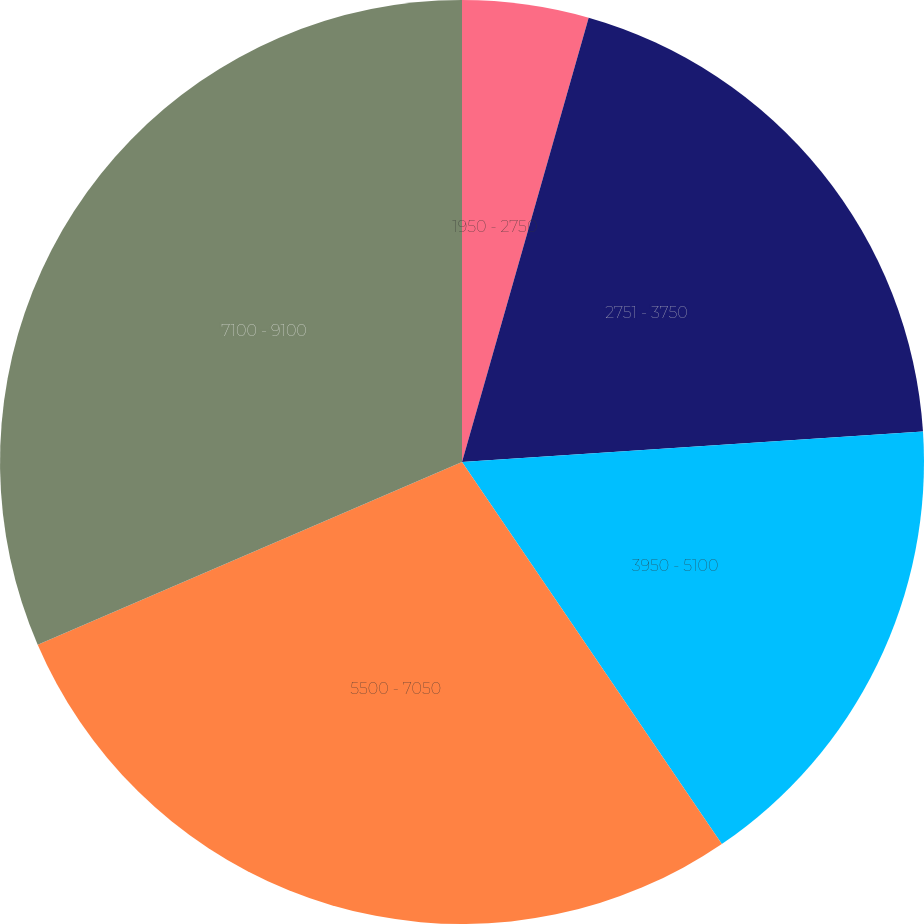Convert chart to OTSL. <chart><loc_0><loc_0><loc_500><loc_500><pie_chart><fcel>1950 - 2750<fcel>2751 - 3750<fcel>3950 - 5100<fcel>5500 - 7050<fcel>7100 - 9100<nl><fcel>4.42%<fcel>19.53%<fcel>16.54%<fcel>28.03%<fcel>31.47%<nl></chart> 